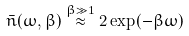Convert formula to latex. <formula><loc_0><loc_0><loc_500><loc_500>\bar { n } ( \omega , \beta ) \overset { \beta \gg 1 } { \approx } 2 \exp ( - \beta \omega )</formula> 